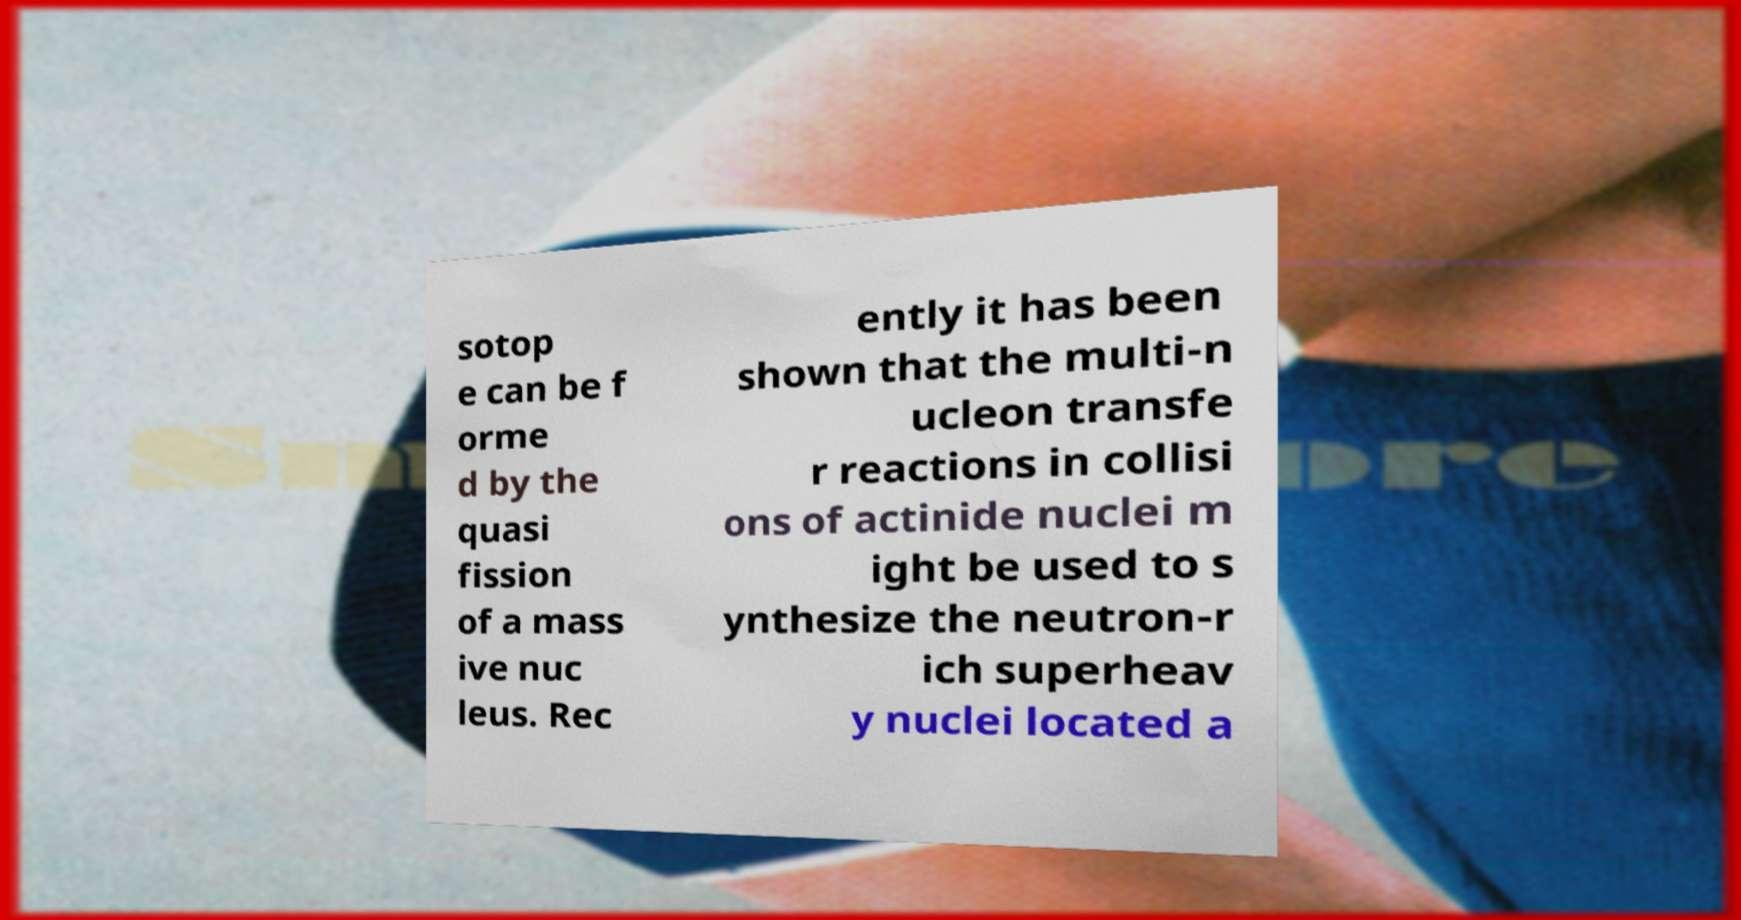For documentation purposes, I need the text within this image transcribed. Could you provide that? sotop e can be f orme d by the quasi fission of a mass ive nuc leus. Rec ently it has been shown that the multi-n ucleon transfe r reactions in collisi ons of actinide nuclei m ight be used to s ynthesize the neutron-r ich superheav y nuclei located a 